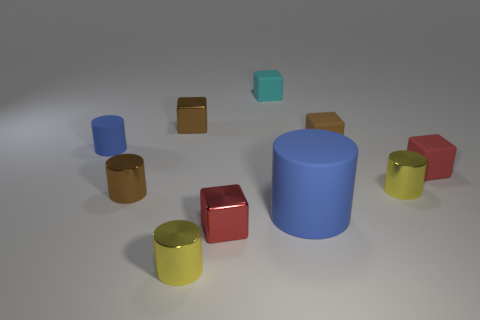Subtract 2 cubes. How many cubes are left? 3 Subtract all cyan blocks. How many blocks are left? 4 Subtract all tiny blue matte cylinders. How many cylinders are left? 4 Subtract all blue blocks. Subtract all brown cylinders. How many blocks are left? 5 Add 5 blue cylinders. How many blue cylinders exist? 7 Subtract 0 purple cylinders. How many objects are left? 10 Subtract all small red cubes. Subtract all tiny brown metallic cubes. How many objects are left? 7 Add 9 tiny cyan cubes. How many tiny cyan cubes are left? 10 